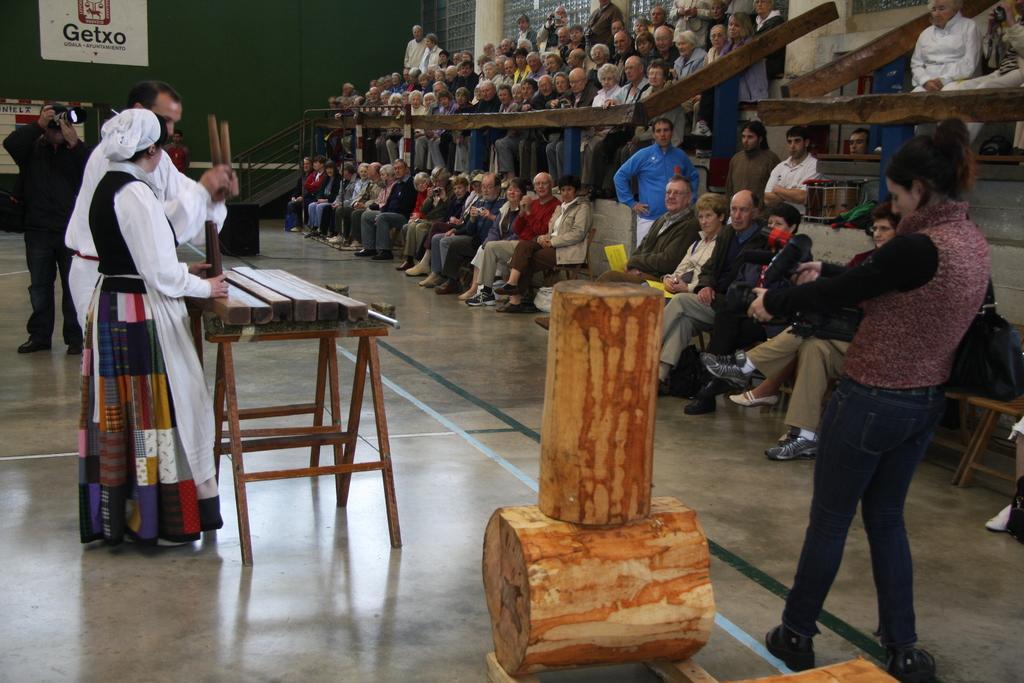Could you give a brief overview of what you see in this image? In this picture two people are standing in front of a table with wooden belonging on top of it. To the right side of the image there is a woman clicking a picture of the wooden object. In the background there are spectators viewing this act. There is also a poster in the background which is named GETXO. 